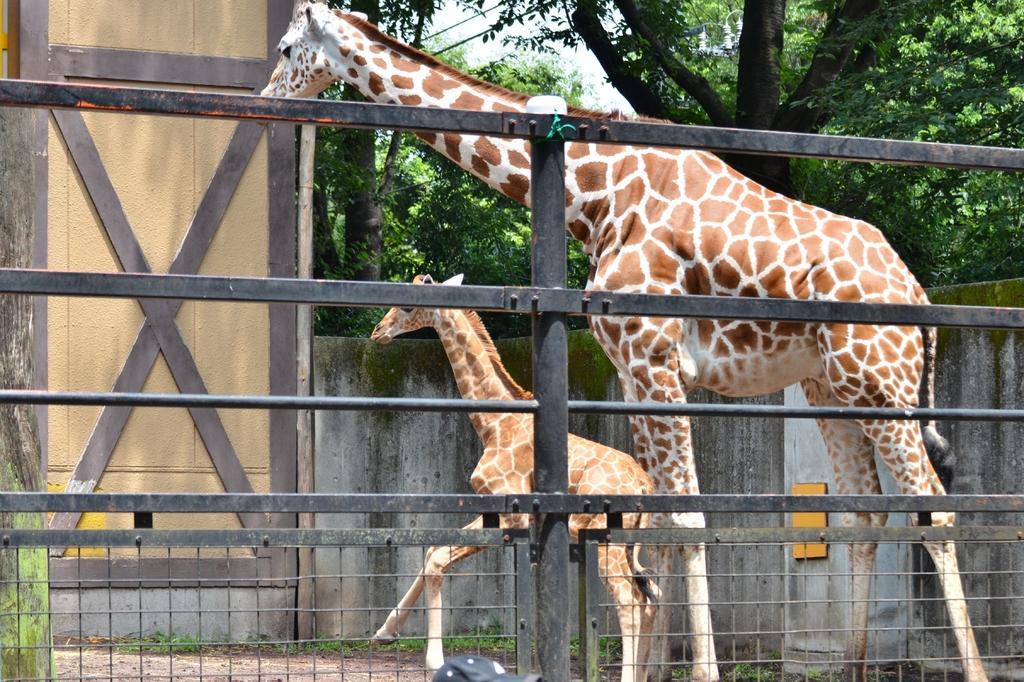How would you summarize this image in a sentence or two? In this image we can see two giraffes and a fence. In the background we can see grass, wall, trees, and sky. 